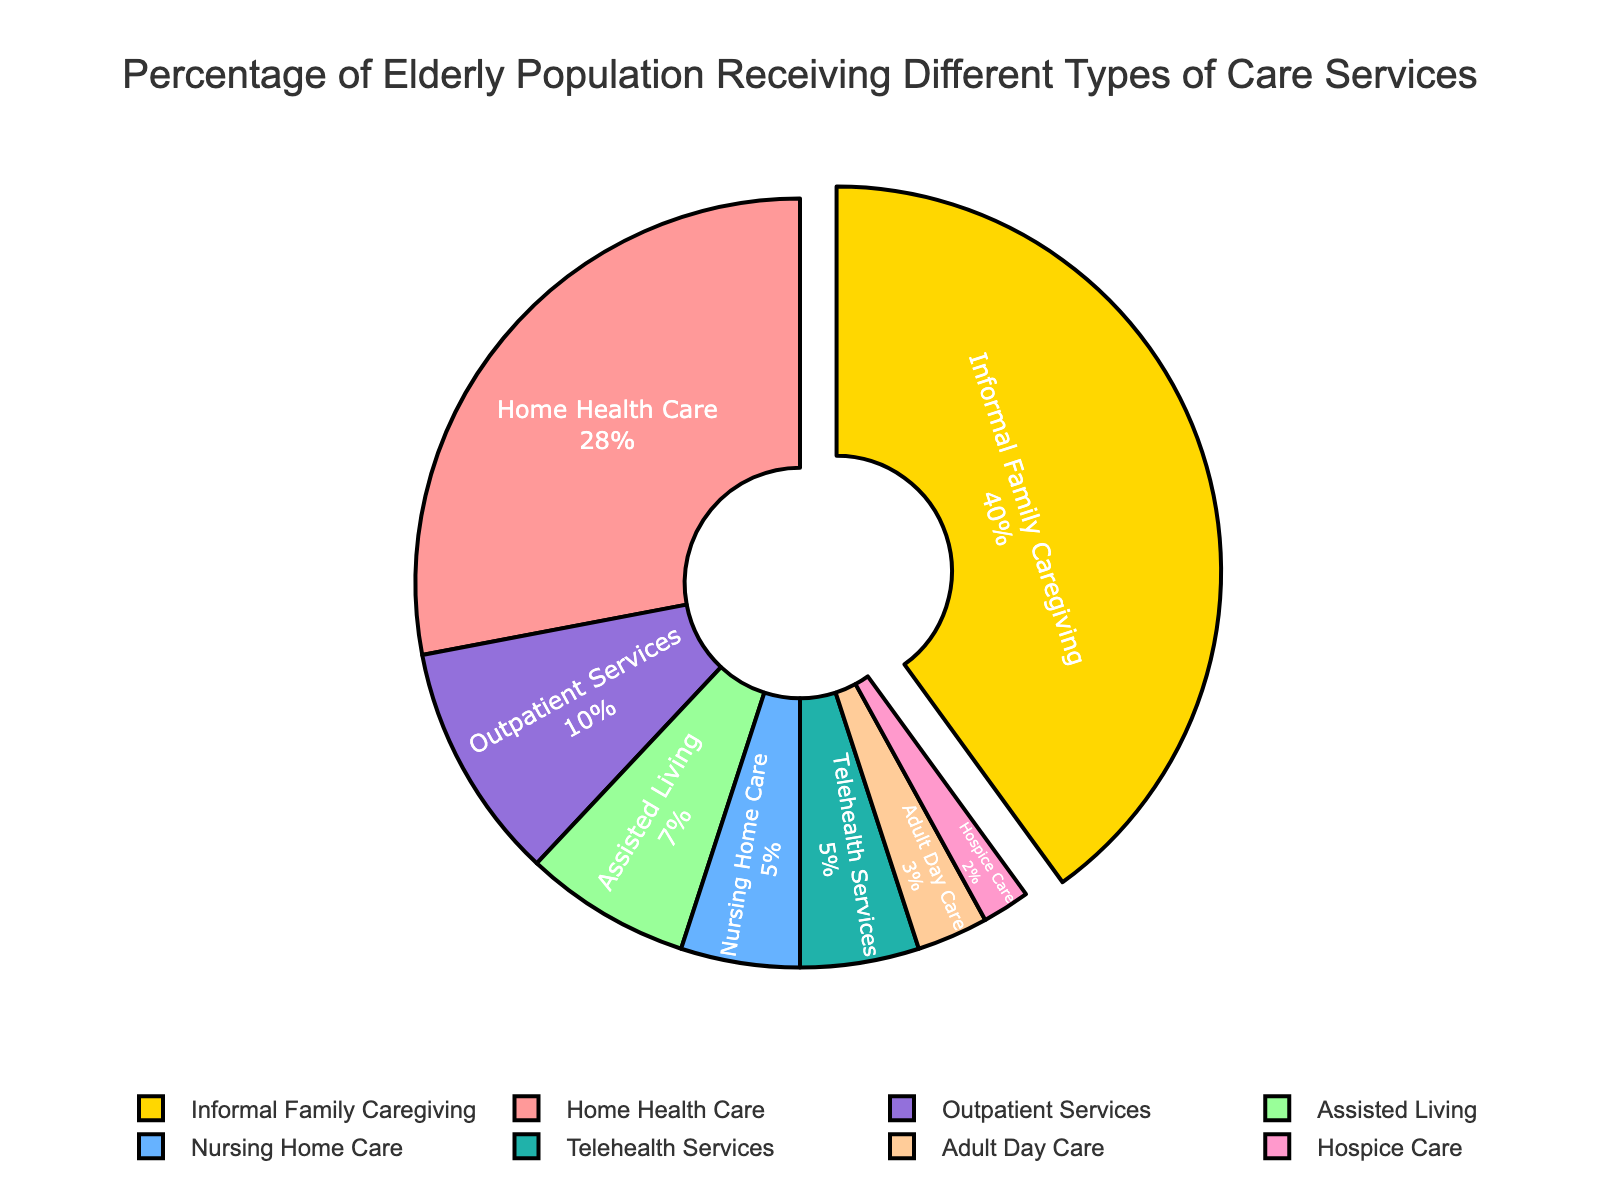Which type of care service has the highest percentage of elderly population receiving it? The pie chart shows that "Informal Family Caregiving" has the largest slice, indicating the highest percentage of the elderly population receiving this type of care.
Answer: Informal Family Caregiving What is the combined percentage of elderly receiving Home Health Care and Nursing Home Care? The percentages for "Home Health Care" and "Nursing Home Care" are 28% and 5%, respectively. Their combined percentage is 28% + 5% = 33%.
Answer: 33% Which care service category accounts for the smallest percentage of elderly care? The pie chart indicates that "Hospice Care" has the smallest slice, representing the lowest percentage of elderly population receiving this type of care at 2%.
Answer: Hospice Care How does the percentage of elderly in Assisted Living compare to those receiving Outpatient Services? "Assisted Living" has a percentage of 7%, while "Outpatient Services" has 10%. Therefore, Outpatient Services are greater than Assisted Living by 3%.
Answer: Outpatient Services is 3% more What is the total percentage of elderly receiving either Adult Day Care, Hospice Care, or Telehealth Services? The percentages are 3% for "Adult Day Care," 2% for "Hospice Care," and 5% for "Telehealth Services." Adding these, the total is 3% + 2% + 5% = 10%.
Answer: 10% Which type of care service, excluding Informal Family Caregiving, has the largest percentage of elderly receiving it? After "Informal Family Caregiving," the next largest segment in the pie chart is "Home Health Care" with 28%.
Answer: Home Health Care If we group Nursing Home Care and Telehealth Services together, what percentage of elderly receive these combined services compared to Home Health Care? "Nursing Home Care" is 5% and "Telehealth Services" is 5%, making a total of 5% + 5% = 10%. "Home Health Care" alone is 28%. So, Home Health Care is 18% more than the combined Nursing Home Care and Telehealth Services.
Answer: Home Health Care is 18% more How many times more elderly receive Informal Family Caregiving than Adult Day Care? "Informal Family Caregiving" is 40% and "Adult Day Care" is 3%. The ratio is 40% / 3% ≈ 13.33. So, approximately 13 times more elderly receive Informal Family Caregiving than Adult Day Care.
Answer: 13 times more Considering all care services, what is the average percentage of elderly receiving each type of care? Adding all percentages: 28% + 5% + 7% + 3% + 2% + 40% + 10% + 5% = 100%. There are 8 types of care services, so the average percentage is 100% / 8 = 12.5%.
Answer: 12.5% What percentage of the elderly receive care services other than Informal Family Caregiving and Home Health Care? Adding the percentages for "Nursing Home Care," "Assisted Living," "Adult Day Care," "Hospice Care," "Outpatient Services," and "Telehealth Services": 5% + 7% + 3% + 2% + 10% + 5% = 32%.
Answer: 32% 